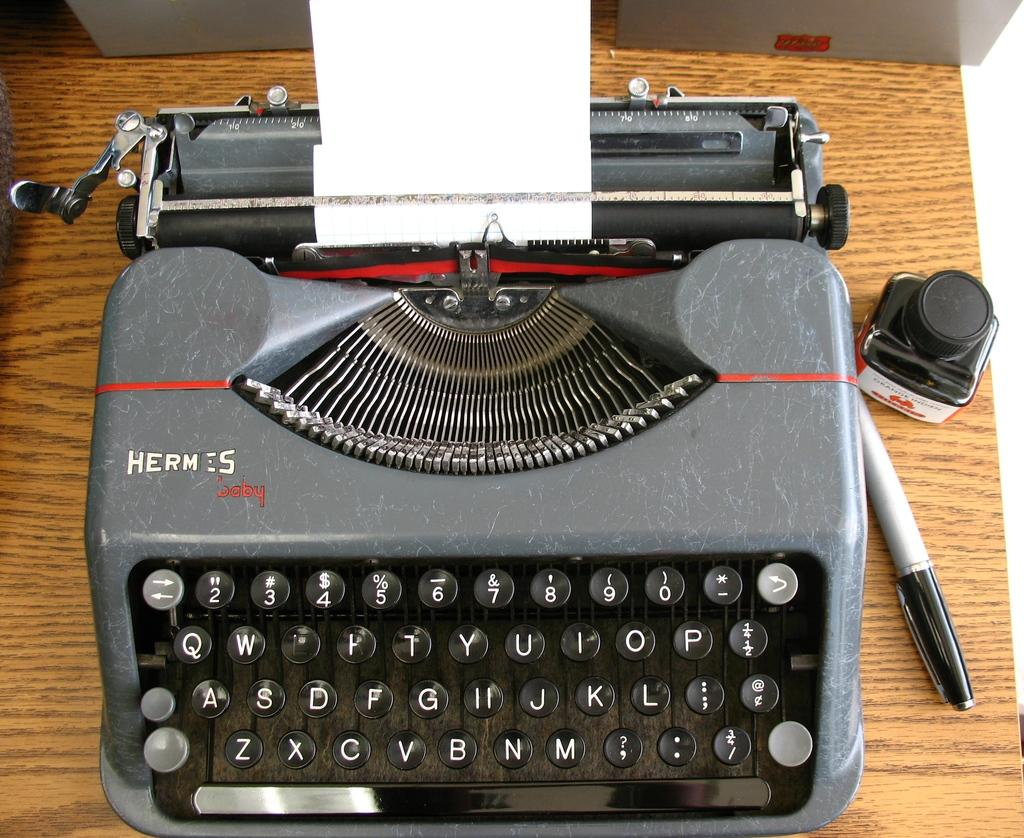Provide a one-sentence caption for the provided image. A old Hermes typewriter and a marker and bottle of ink sitting next to it. 